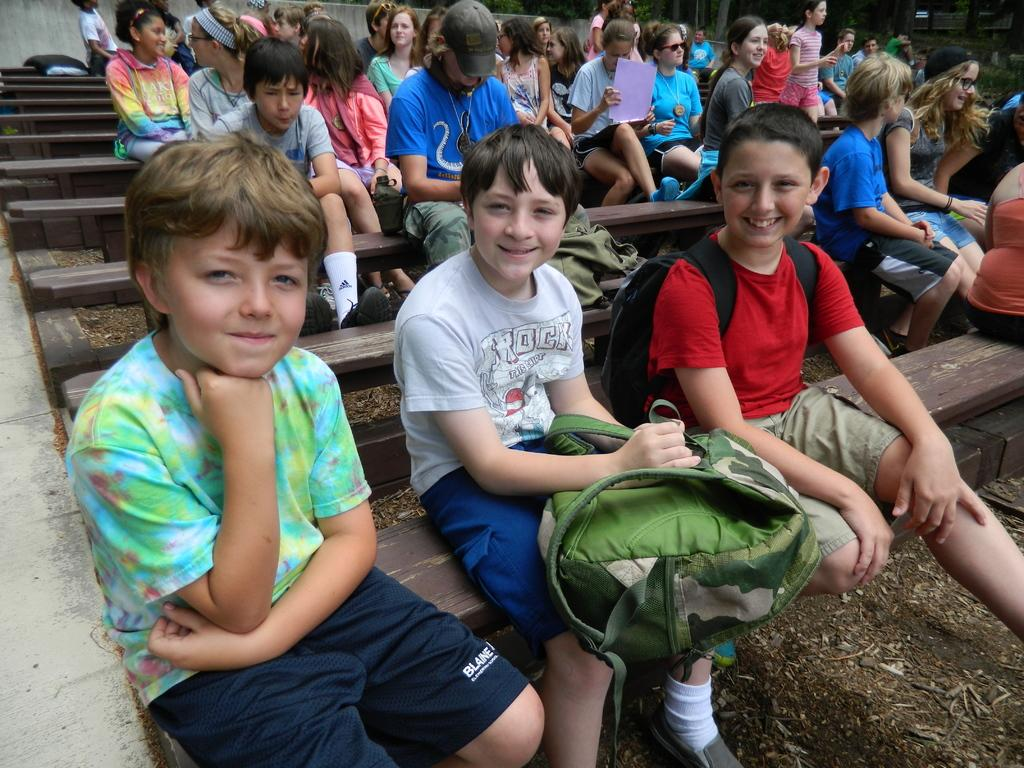What type of seating is present in the image? There are benches in the image. Who is sitting on the benches? Boys and girls are sitting on the benches. What items can be seen near the children? There are backpacks visible in the image. What can be seen in the background of the image? There are trees and a wall in the background of the image. What type of ocean can be seen in the image? There is no ocean present in the image. Is there any smoke visible in the image? There is no smoke visible in the image. 